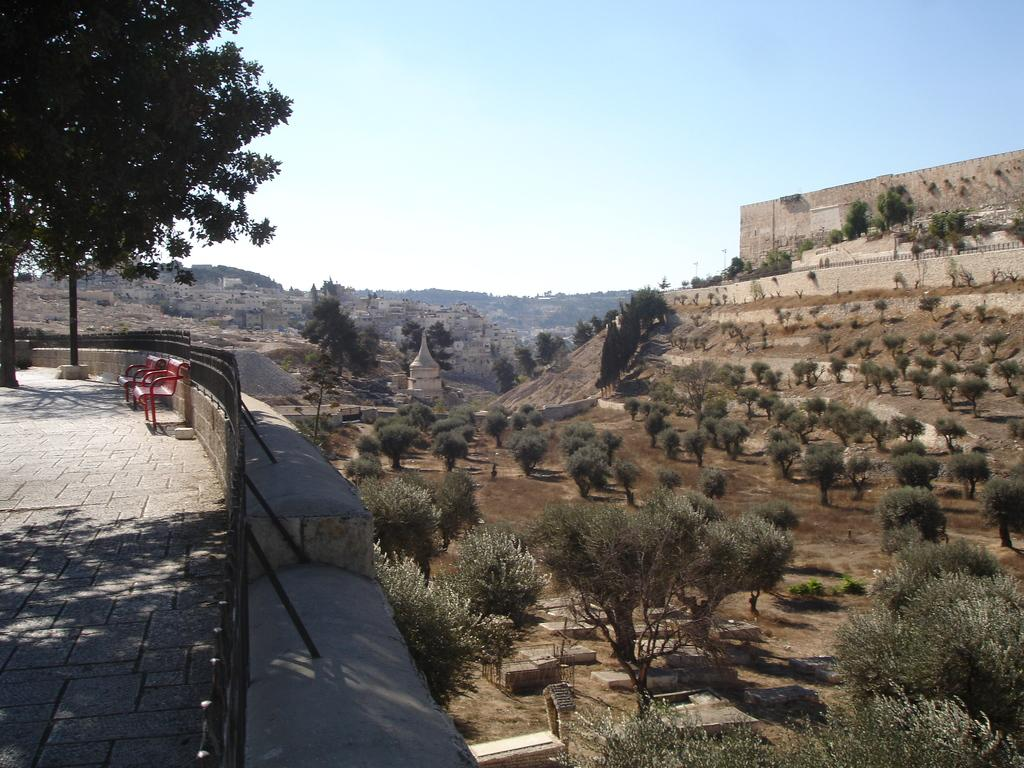What type of surface is visible at the bottom of the image? There is a floor visible in the image. What is located on the left side of the image? There is a wall on the left side of the image. What type of vegetation is on the right side of the image? There are plants and trees on the right side of the image. What is visible at the top of the image? The sky is visible at the top of the image. What type of wool is being used to create the organization of houses in the image? There is no wool or organization of houses present in the image. What type of wool is being used to create the plants in the image? There is no wool present in the image; the plants are natural vegetation. 